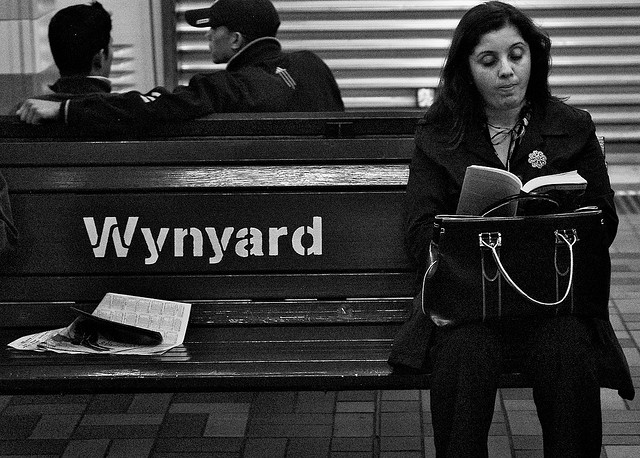Extract all visible text content from this image. Wynyard 